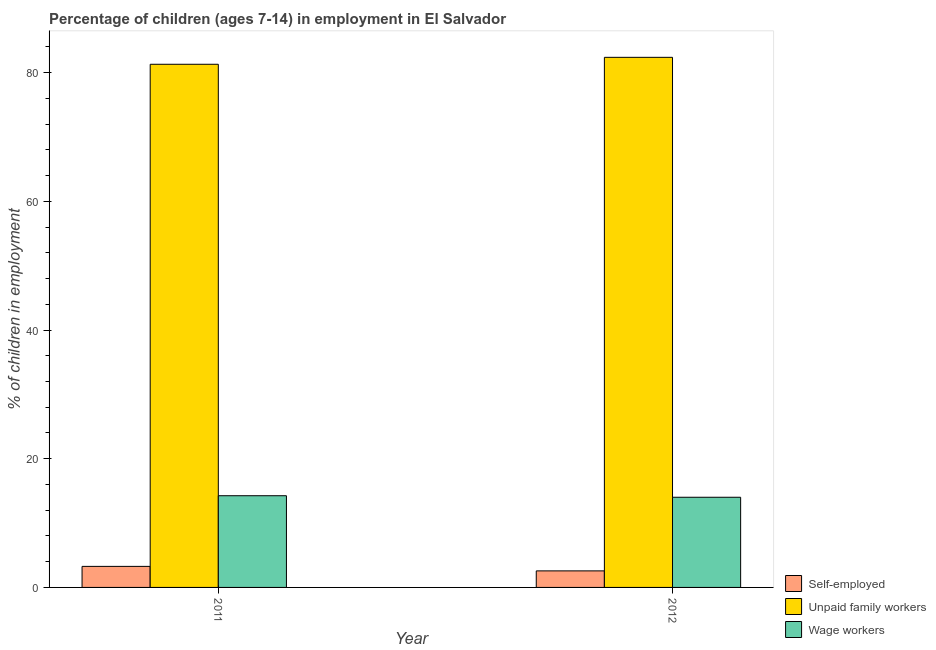Are the number of bars per tick equal to the number of legend labels?
Provide a succinct answer. Yes. Are the number of bars on each tick of the X-axis equal?
Provide a succinct answer. Yes. How many bars are there on the 2nd tick from the right?
Your response must be concise. 3. What is the percentage of children employed as unpaid family workers in 2011?
Offer a very short reply. 81.29. Across all years, what is the maximum percentage of self employed children?
Provide a short and direct response. 3.27. Across all years, what is the minimum percentage of children employed as unpaid family workers?
Provide a short and direct response. 81.29. In which year was the percentage of children employed as wage workers minimum?
Your response must be concise. 2012. What is the total percentage of self employed children in the graph?
Provide a succinct answer. 5.84. What is the difference between the percentage of children employed as unpaid family workers in 2011 and that in 2012?
Provide a succinct answer. -1.08. What is the difference between the percentage of children employed as unpaid family workers in 2011 and the percentage of children employed as wage workers in 2012?
Offer a very short reply. -1.08. What is the average percentage of children employed as wage workers per year?
Your answer should be compact. 14.13. In the year 2012, what is the difference between the percentage of self employed children and percentage of children employed as wage workers?
Keep it short and to the point. 0. What is the ratio of the percentage of children employed as wage workers in 2011 to that in 2012?
Offer a terse response. 1.02. What does the 3rd bar from the left in 2012 represents?
Your answer should be very brief. Wage workers. What does the 2nd bar from the right in 2012 represents?
Your answer should be very brief. Unpaid family workers. Is it the case that in every year, the sum of the percentage of self employed children and percentage of children employed as unpaid family workers is greater than the percentage of children employed as wage workers?
Your answer should be compact. Yes. Are all the bars in the graph horizontal?
Your answer should be compact. No. How many years are there in the graph?
Offer a very short reply. 2. What is the title of the graph?
Your answer should be very brief. Percentage of children (ages 7-14) in employment in El Salvador. What is the label or title of the Y-axis?
Provide a short and direct response. % of children in employment. What is the % of children in employment in Self-employed in 2011?
Your answer should be very brief. 3.27. What is the % of children in employment of Unpaid family workers in 2011?
Provide a short and direct response. 81.29. What is the % of children in employment in Wage workers in 2011?
Your answer should be very brief. 14.25. What is the % of children in employment in Self-employed in 2012?
Ensure brevity in your answer.  2.57. What is the % of children in employment in Unpaid family workers in 2012?
Provide a short and direct response. 82.37. What is the % of children in employment in Wage workers in 2012?
Make the answer very short. 14.01. Across all years, what is the maximum % of children in employment of Self-employed?
Keep it short and to the point. 3.27. Across all years, what is the maximum % of children in employment in Unpaid family workers?
Your response must be concise. 82.37. Across all years, what is the maximum % of children in employment in Wage workers?
Give a very brief answer. 14.25. Across all years, what is the minimum % of children in employment in Self-employed?
Provide a short and direct response. 2.57. Across all years, what is the minimum % of children in employment of Unpaid family workers?
Give a very brief answer. 81.29. Across all years, what is the minimum % of children in employment of Wage workers?
Provide a short and direct response. 14.01. What is the total % of children in employment in Self-employed in the graph?
Provide a succinct answer. 5.84. What is the total % of children in employment in Unpaid family workers in the graph?
Make the answer very short. 163.66. What is the total % of children in employment of Wage workers in the graph?
Ensure brevity in your answer.  28.26. What is the difference between the % of children in employment of Self-employed in 2011 and that in 2012?
Provide a succinct answer. 0.7. What is the difference between the % of children in employment of Unpaid family workers in 2011 and that in 2012?
Offer a very short reply. -1.08. What is the difference between the % of children in employment in Wage workers in 2011 and that in 2012?
Offer a very short reply. 0.24. What is the difference between the % of children in employment in Self-employed in 2011 and the % of children in employment in Unpaid family workers in 2012?
Your answer should be compact. -79.1. What is the difference between the % of children in employment in Self-employed in 2011 and the % of children in employment in Wage workers in 2012?
Offer a terse response. -10.74. What is the difference between the % of children in employment of Unpaid family workers in 2011 and the % of children in employment of Wage workers in 2012?
Make the answer very short. 67.28. What is the average % of children in employment in Self-employed per year?
Give a very brief answer. 2.92. What is the average % of children in employment in Unpaid family workers per year?
Your response must be concise. 81.83. What is the average % of children in employment in Wage workers per year?
Provide a short and direct response. 14.13. In the year 2011, what is the difference between the % of children in employment in Self-employed and % of children in employment in Unpaid family workers?
Your answer should be compact. -78.02. In the year 2011, what is the difference between the % of children in employment of Self-employed and % of children in employment of Wage workers?
Give a very brief answer. -10.98. In the year 2011, what is the difference between the % of children in employment of Unpaid family workers and % of children in employment of Wage workers?
Keep it short and to the point. 67.04. In the year 2012, what is the difference between the % of children in employment in Self-employed and % of children in employment in Unpaid family workers?
Provide a short and direct response. -79.8. In the year 2012, what is the difference between the % of children in employment in Self-employed and % of children in employment in Wage workers?
Your answer should be compact. -11.44. In the year 2012, what is the difference between the % of children in employment of Unpaid family workers and % of children in employment of Wage workers?
Provide a short and direct response. 68.36. What is the ratio of the % of children in employment of Self-employed in 2011 to that in 2012?
Keep it short and to the point. 1.27. What is the ratio of the % of children in employment of Unpaid family workers in 2011 to that in 2012?
Your answer should be compact. 0.99. What is the ratio of the % of children in employment in Wage workers in 2011 to that in 2012?
Give a very brief answer. 1.02. What is the difference between the highest and the second highest % of children in employment in Self-employed?
Offer a very short reply. 0.7. What is the difference between the highest and the second highest % of children in employment of Unpaid family workers?
Offer a terse response. 1.08. What is the difference between the highest and the second highest % of children in employment of Wage workers?
Provide a short and direct response. 0.24. What is the difference between the highest and the lowest % of children in employment in Unpaid family workers?
Your answer should be very brief. 1.08. What is the difference between the highest and the lowest % of children in employment in Wage workers?
Offer a very short reply. 0.24. 